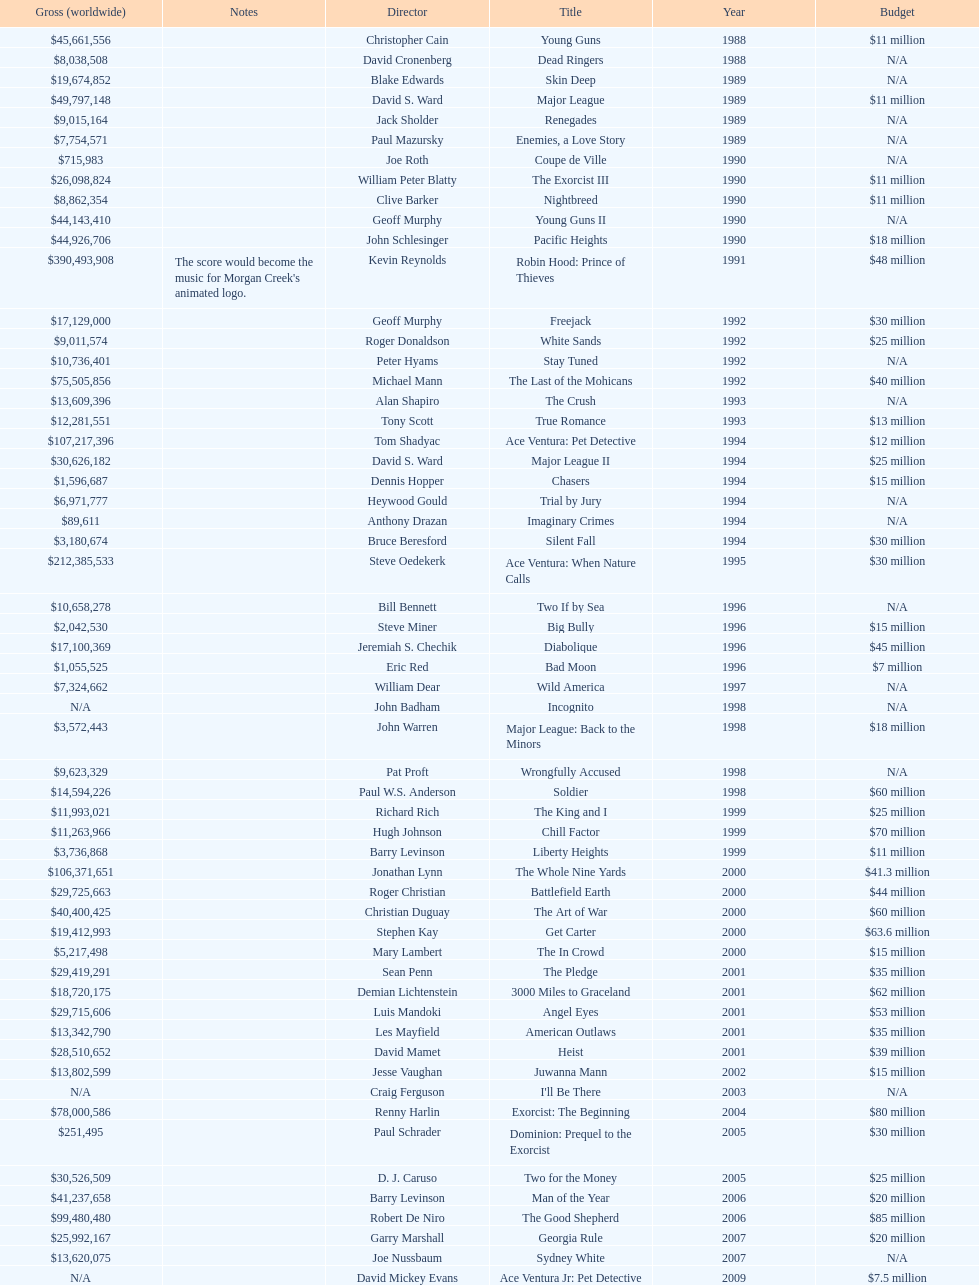What was the last movie morgan creek made for a budget under thirty million? Ace Ventura Jr: Pet Detective. 